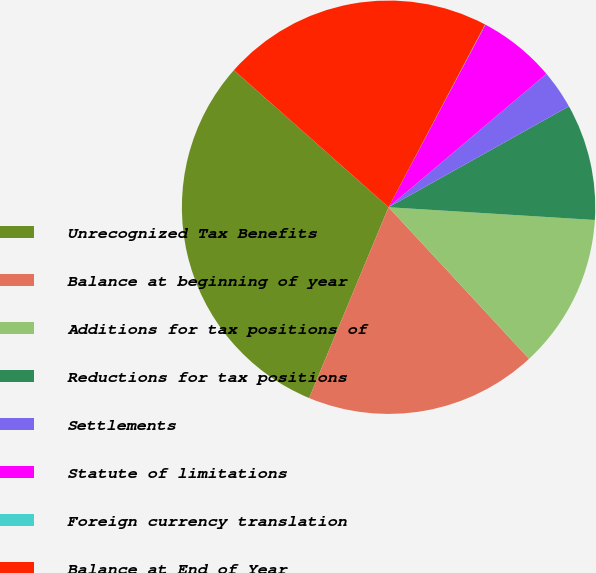Convert chart. <chart><loc_0><loc_0><loc_500><loc_500><pie_chart><fcel>Unrecognized Tax Benefits<fcel>Balance at beginning of year<fcel>Additions for tax positions of<fcel>Reductions for tax positions<fcel>Settlements<fcel>Statute of limitations<fcel>Foreign currency translation<fcel>Balance at End of Year<nl><fcel>30.26%<fcel>18.17%<fcel>12.12%<fcel>9.1%<fcel>3.05%<fcel>6.07%<fcel>0.03%<fcel>21.19%<nl></chart> 